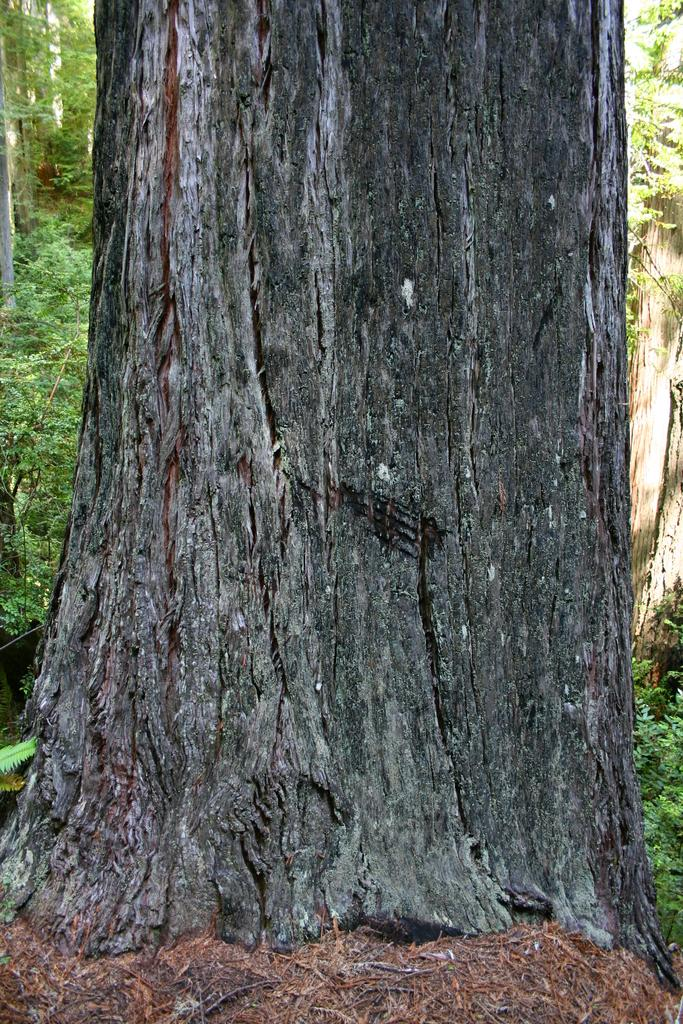What is the main subject of the picture? The main subject of the picture is a tree trunk. Can you describe the surrounding environment in the picture? There are additional trees visible in the background of the picture. What type of pencil can be seen in the picture? There is no pencil present in the picture; it features a tree trunk and additional trees in the background. What boundary is visible in the picture? There is no boundary visible in the picture; it features a tree trunk and additional trees in the background. 